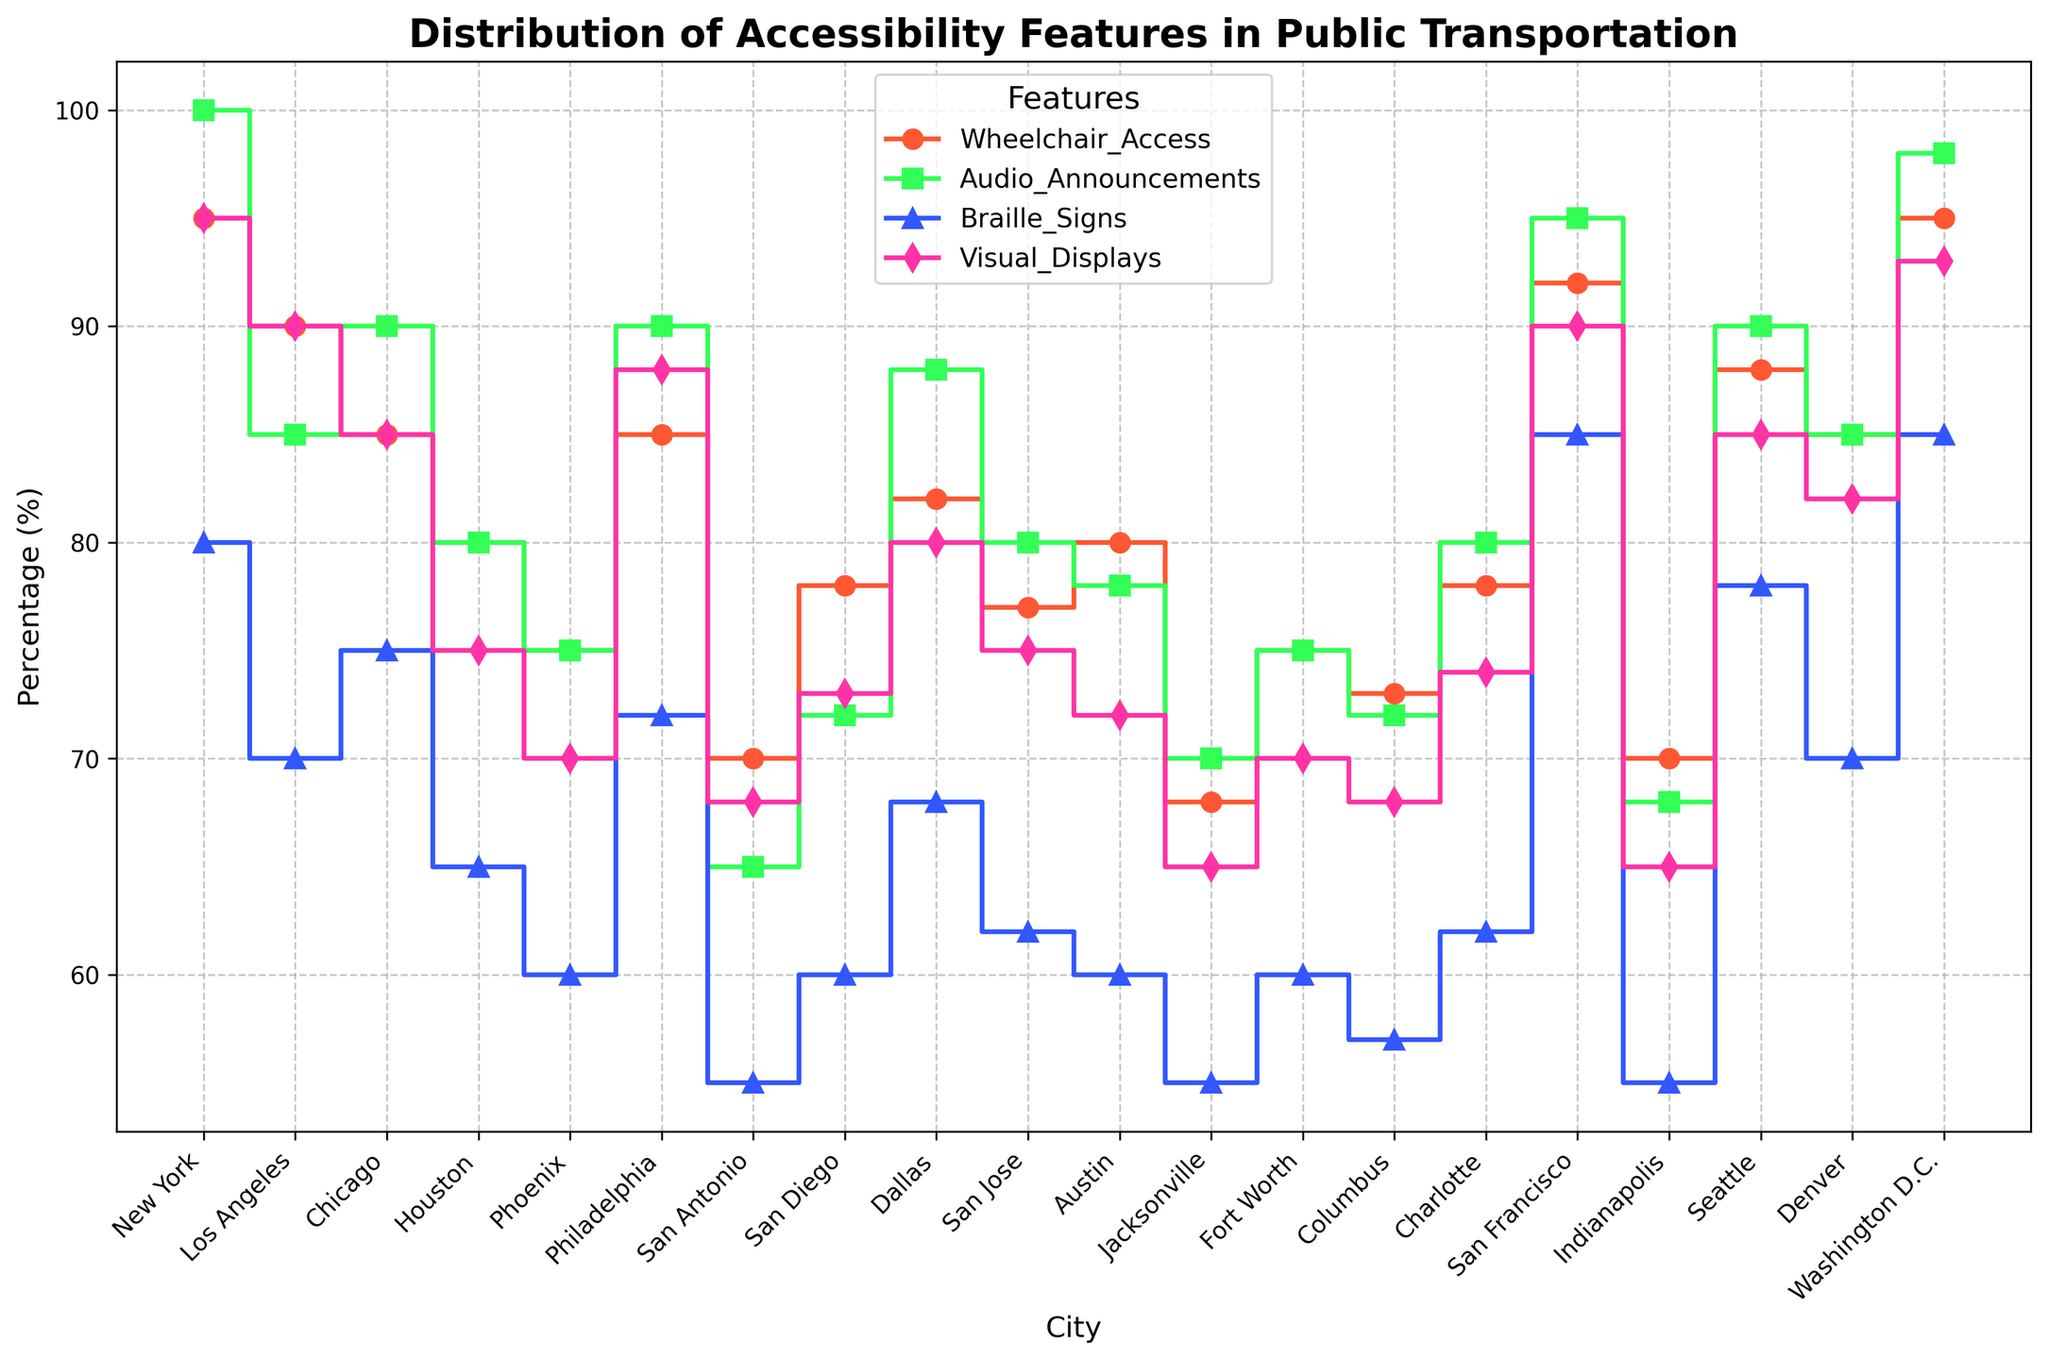Which city has the highest percentage of wheelchair access? The figure shows the distribution of accessibility features for different cities. The city with the highest percentage of wheelchair access is found by identifying the city with the highest marker along the green line (representing wheelchair access) at 95%.
Answer: New York and Washington D.C Which city has the lowest percentage of braille signs? By observing the step plot, the city with the lowest percentage of braille signs is indicated on the yellow line (representing braille signs) at 55%.
Answer: San Antonio, Jacksonville, and Indianapolis What is the approximate difference in the percentage of visual displays between New York and Los Angeles? Find the percentage of visual displays for New York (95%) and Los Angeles (90%). Subtract the latter from the former: 95% - 90%.
Answer: 5% Which accessibility feature has the most variation across cities? To determine the feature with the most variation, look at the spread of each line in the plot. The feature with the widest range between its highest and lowest points has the most variation.
Answer: Wheelchair Access What is the average percentage of audio announcements across all cities? To find the average, sum up the percentages of audio announcements for all cities and divide by the number of cities. The sum is 100 + 85 + 90 + 80 + 75 + 90 + 65 + 72 + 88 + 80 + 78 + 70 + 75 + 72 + 80 + 95 + 68 + 90 + 85 + 98 = 1776. There are 20 cities, so the average is 1776 / 20.
Answer: 88.8% Compare the percentages of visual displays and braille signs in San Francisco. Which one is higher and by how much? Visual displays in San Francisco are at 90% and braille signs are at 85%. Subtract the braille signs percentage from the visual displays percentage: 90% - 85%.
Answer: Visual displays are higher by 5% In which city is the percentage of audio announcements and braille signs exactly equal? Compare the percentages of audio announcements and braille signs for each city. Find the city where both percentages are the same.
Answer: None What is the total percentage of accessibility features in Chicago? Sum the percentages of all features for Chicago: 85% (Wheelchair Access) + 90% (Audio Announcements) + 75% (Braille Signs) + 85% (Visual Displays).
Answer: 335% How does the percentage of wheelchair access in Phoenix compare to that in Dallas? Look at the percentages of wheelchair access for Phoenix (75%) and Dallas (82%). Phoenix has a lower percentage than Dallas.
Answer: Phoenix is lower by 7% Which city has the most balanced distribution of the four accessibility features? (Feature percentages are closest to each other) The most balanced distribution can be observed by looking for the city where the features' values are the closest to each other. This would be where the markers for each feature on the plot are close together with minimal difference.
Answer: Washington D.C 